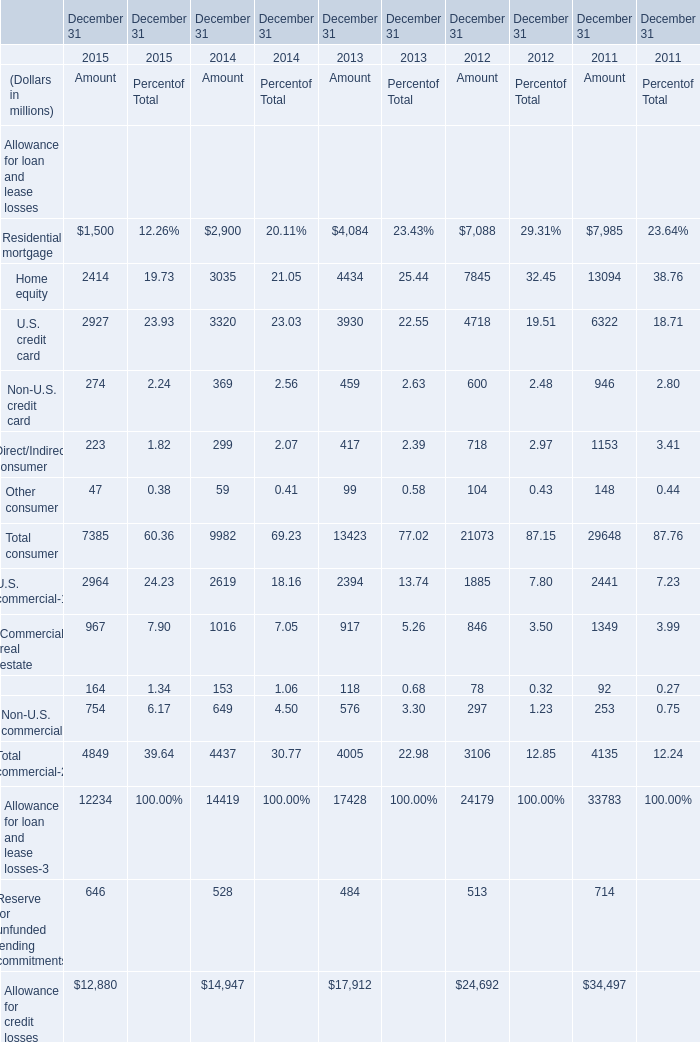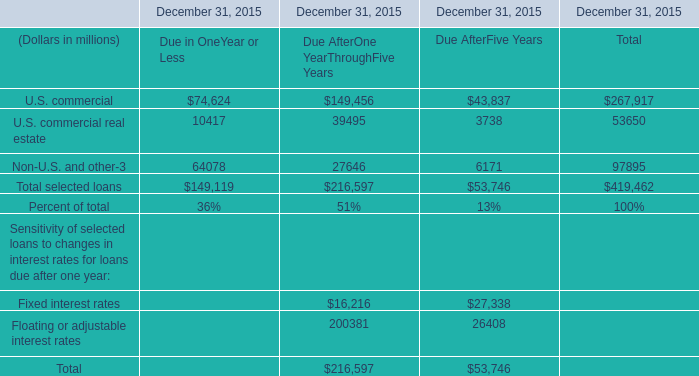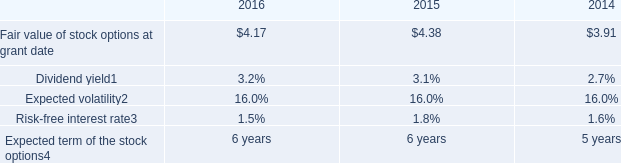In what year is Home equity greater than 10000? 
Answer: 2011. 